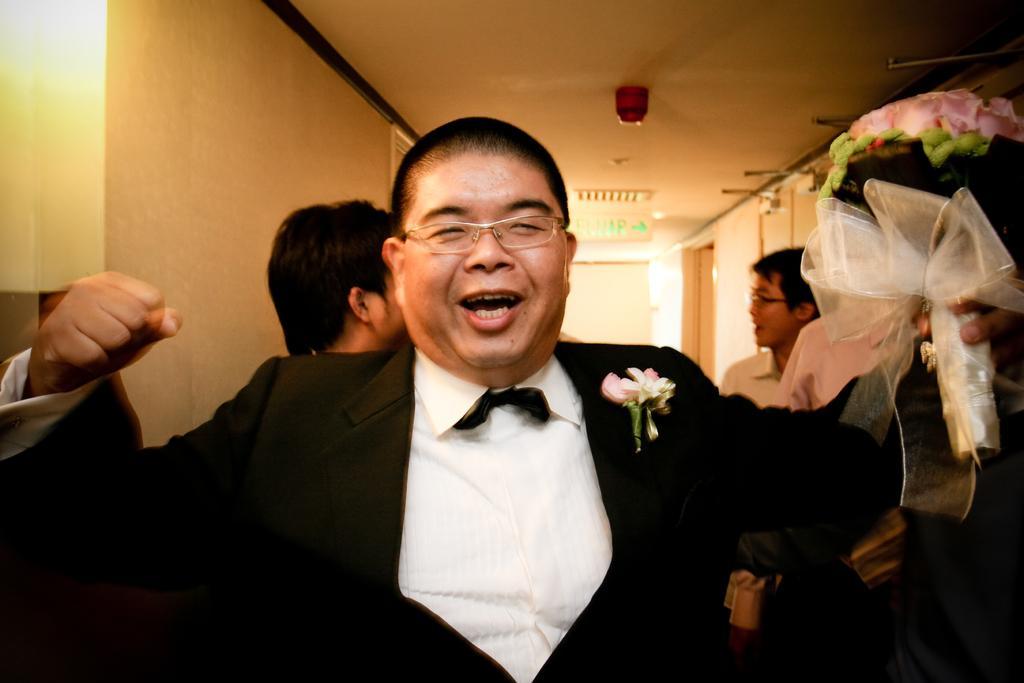Could you give a brief overview of what you see in this image? In this image, we can see a person in a suit is holding a flower bouquet and smiling. Background we can see people's, wall, sign board, ceiling and few objects. 